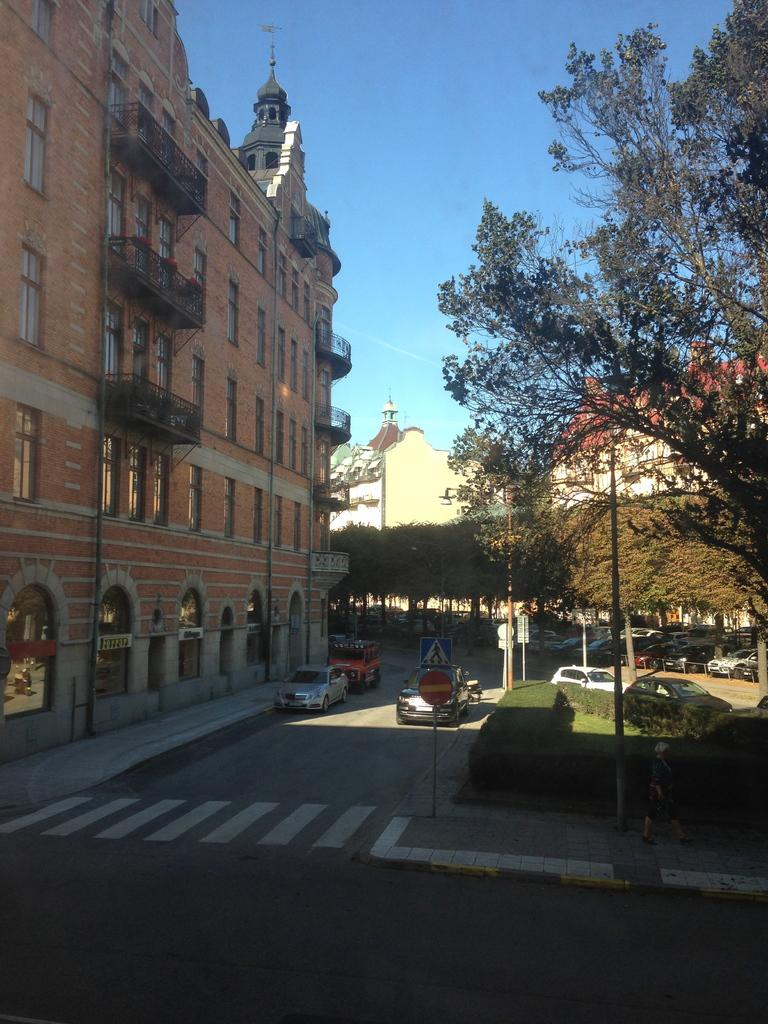What type of pathway is visible in the image? There is a road in the image. What vehicles can be seen on the road? There are cars in the image. What structures are present in the image? There are buildings in the image. What type of vegetation is visible in the image? There are trees and grass in the image. What part of the natural environment is visible in the image? The sky is visible in the image. What is the purpose of the kettle in the image? There is no kettle present in the image, so it is not possible to determine its purpose. 